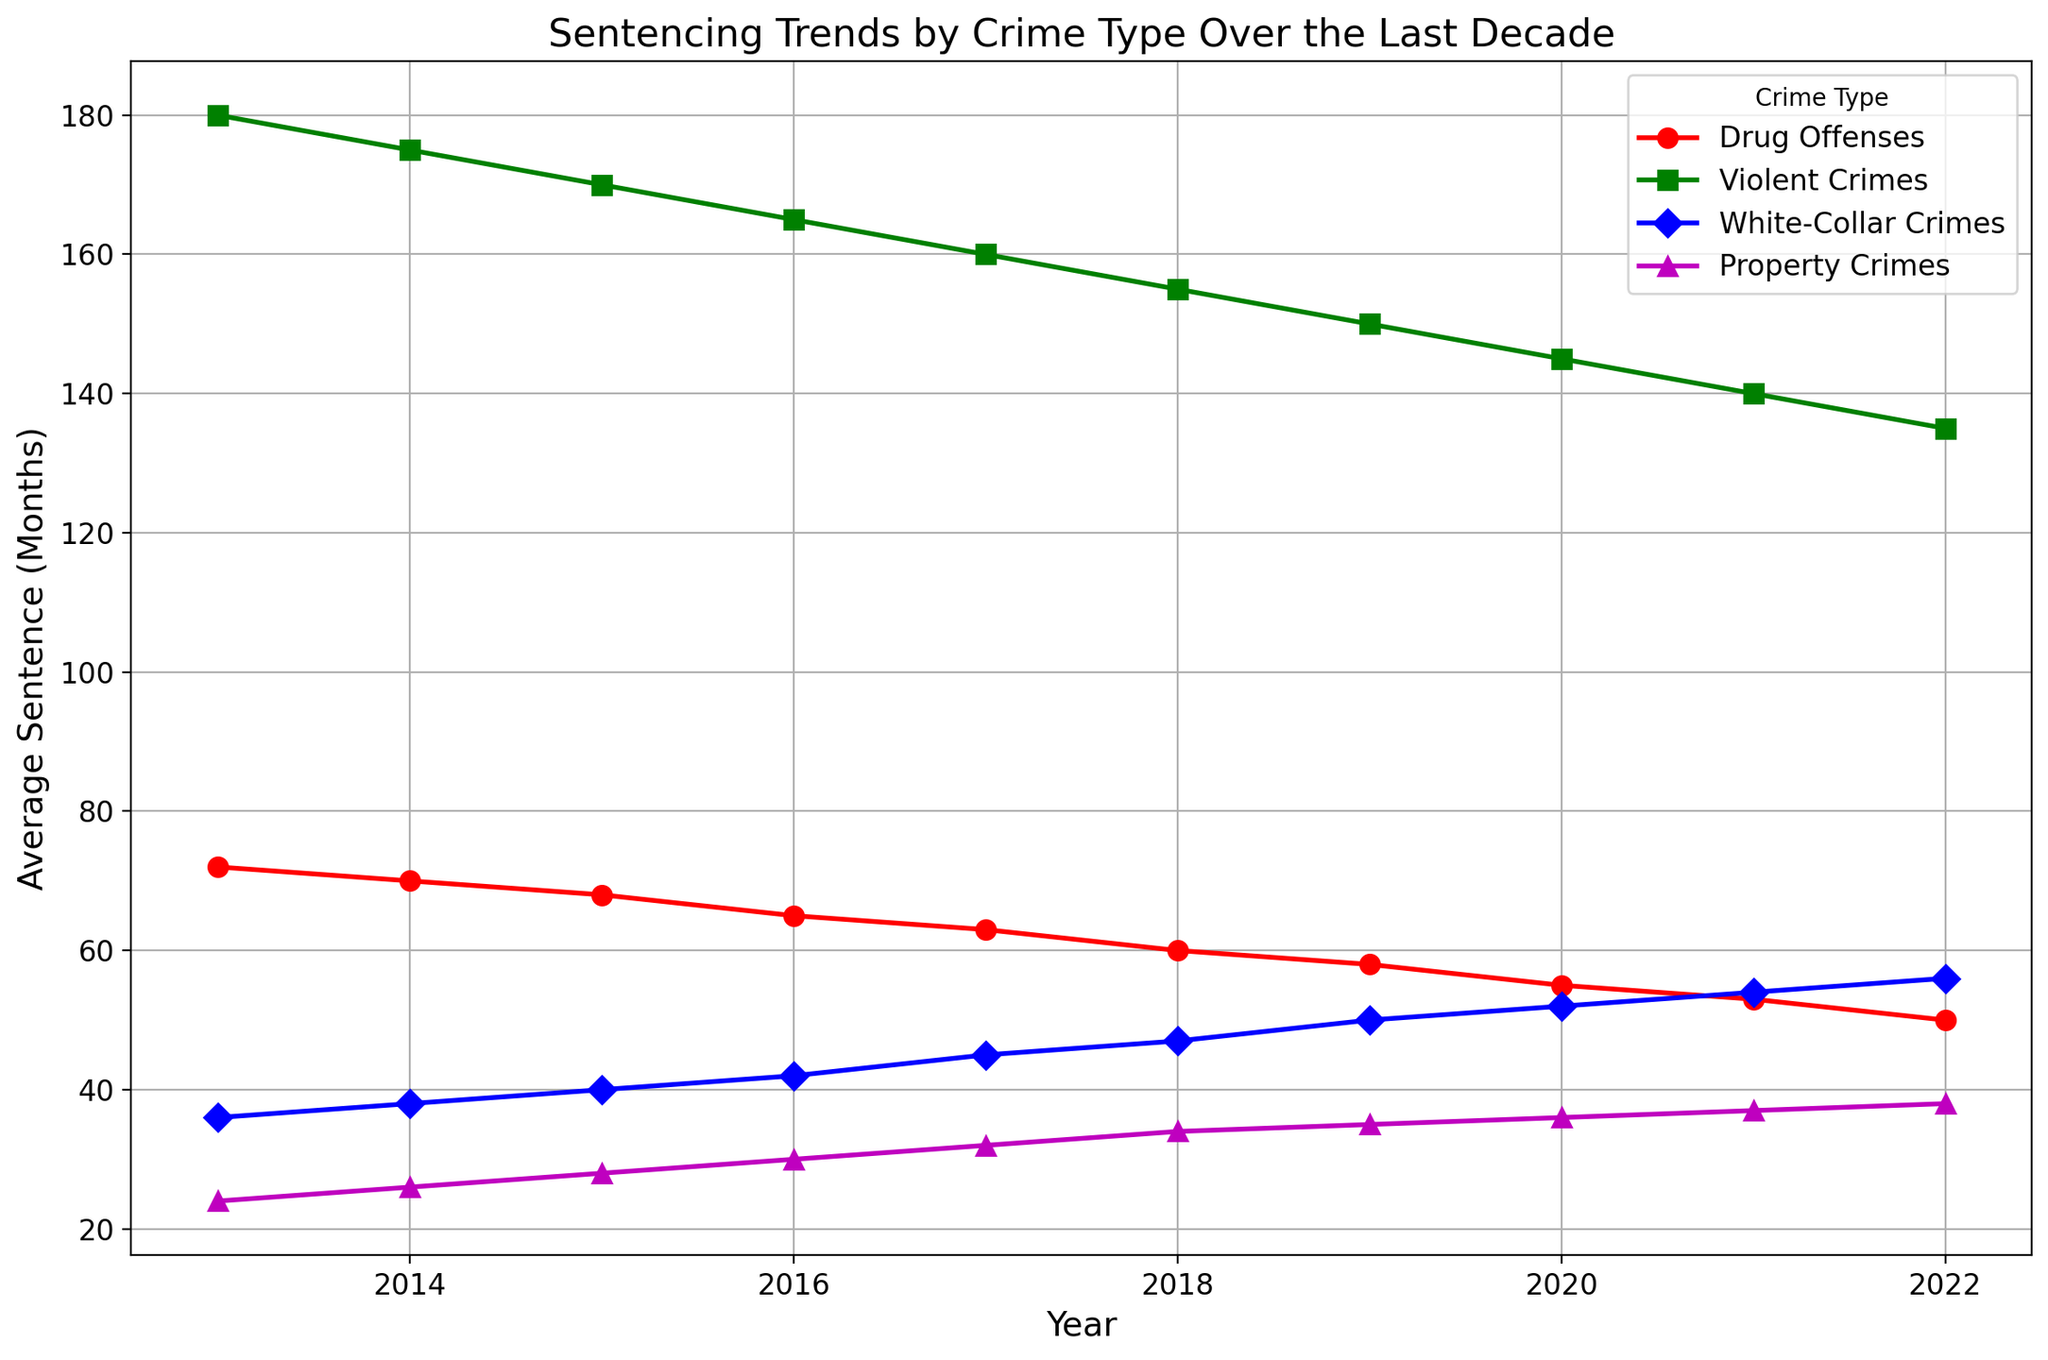What was the average sentence for violent crimes in 2016? Look at the point on the plot for the year 2016 and the crime type “Violent Crimes”; the y-value is 165.
Answer: 165 months Which crime type showed the largest decrease in average sentence from 2013 to 2022? Compare the starting and ending values for each crime type between 2013 and 2022. Violent crimes decreased from 180 to 135 months, which is the largest decrease of 45 months.
Answer: Violent Crimes How did the average sentence for property crimes change from 2013 to 2016? Look at the points for property crimes between 2013 and 2016. It increased from 24 to 30 months.
Answer: Increased by 6 months What is the average sentence length for white-collar crimes in 2020 and 2021? Check the y-values for white-collar crimes in 2020 and 2021. They are 52 and 54 months, respectively.
Answer: 53 months Compare the trends of average sentences for drug offenses and white-collar crimes over the decade. Drug offenses showed a steady decline from 72 to 50 months, while white-collar crimes generally increased from 36 to 56 months.
Answer: Drug offenses decreased, white-collar increased What was the difference in the average sentence for violent crimes and drug offenses in 2018? Locate the points for violent crimes and drug offenses in 2018. Violent crimes are at 155 months, and drug offenses are at 60 months. The difference is 155 - 60 = 95 months.
Answer: 95 months Which crime type had the least fluctuation in average sentence over the decade? Observe the plots for all crime types. White-collar crimes show the least fluctuation with a steady increase from 36 to 56 months.
Answer: White-Collar Crimes How much did the average sentence for property crimes increase from 2015 to 2022? Look at the points for property crimes in 2015 and 2022. It increased from 28 to 38 months.
Answer: Increased by 10 months If you average the average sentence for drug offenses and violent crimes in 2021, what do you get? Drug offenses in 2021 are 53 months and violent crimes are 140 months. The average is (53 + 140) / 2 = 96.5 months.
Answer: 96.5 months 